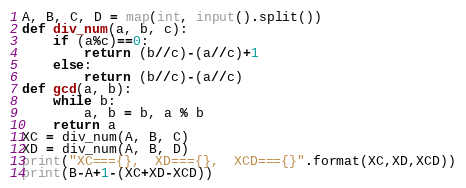Convert code to text. <code><loc_0><loc_0><loc_500><loc_500><_Python_>A, B, C, D = map(int, input().split())
def div_num(a, b, c):
    if (a%c)==0:
        return (b//c)-(a//c)+1
    else:
        return (b//c)-(a//c)
def gcd(a, b):
    while b:
        a, b = b, a % b
    return a
XC = div_num(A, B, C)
XD = div_num(A, B, D)
print("XC==={},  XD==={},  XCD==={}".format(XC,XD,XCD))
print(B-A+1-(XC+XD-XCD))</code> 